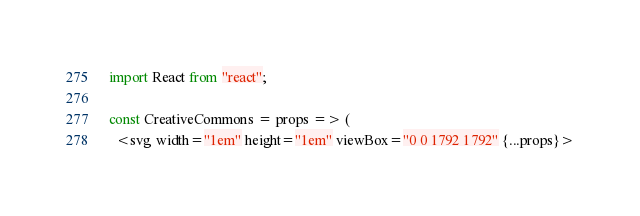<code> <loc_0><loc_0><loc_500><loc_500><_JavaScript_>import React from "react";

const CreativeCommons = props => (
  <svg width="1em" height="1em" viewBox="0 0 1792 1792" {...props}></code> 